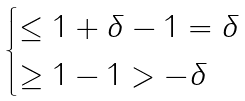Convert formula to latex. <formula><loc_0><loc_0><loc_500><loc_500>\begin{cases} \leq 1 + \delta - 1 = \delta \\ \geq 1 - 1 > - \delta \end{cases}</formula> 